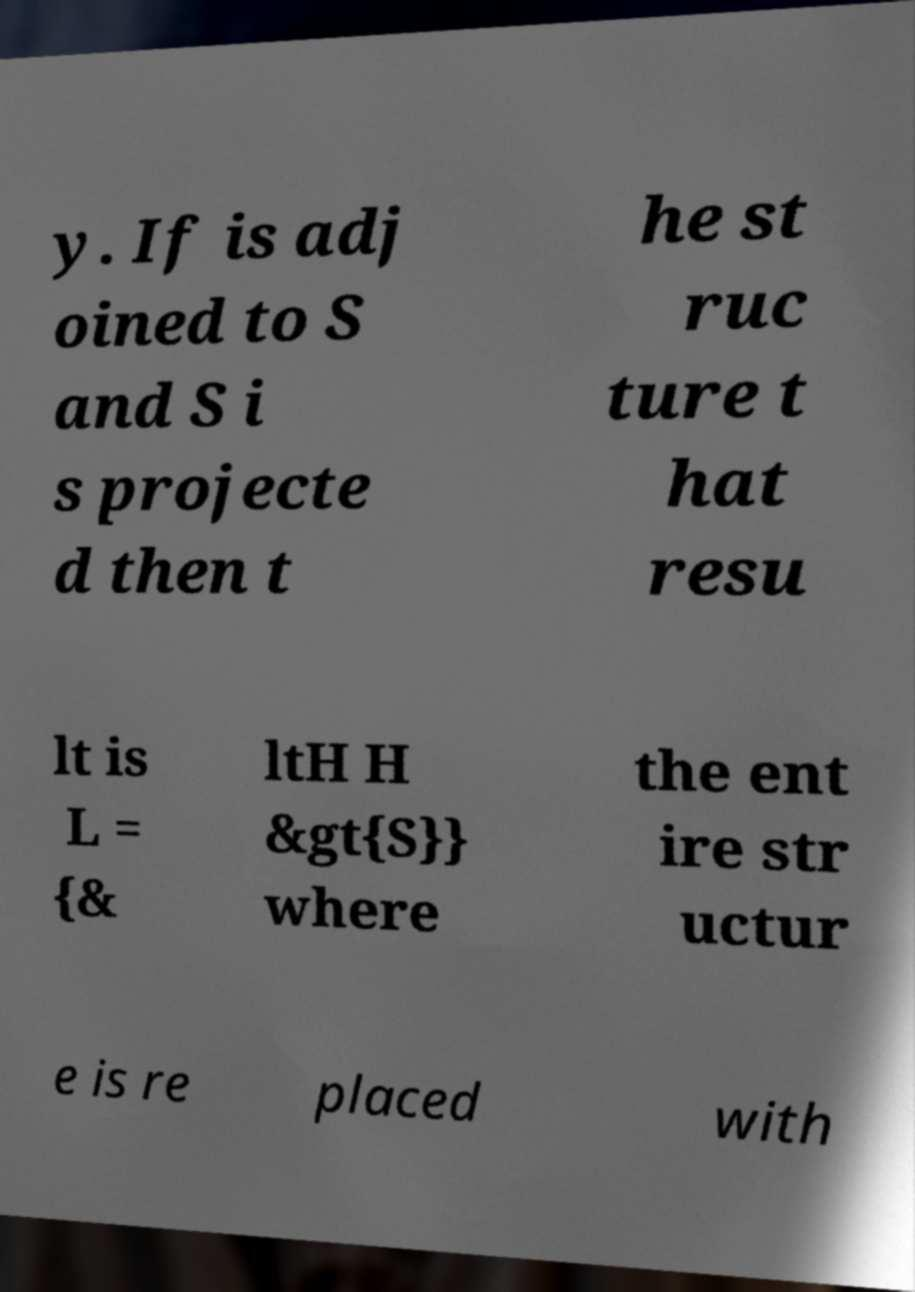There's text embedded in this image that I need extracted. Can you transcribe it verbatim? y. If is adj oined to S and S i s projecte d then t he st ruc ture t hat resu lt is L = {& ltH H &gt{S}} where the ent ire str uctur e is re placed with 